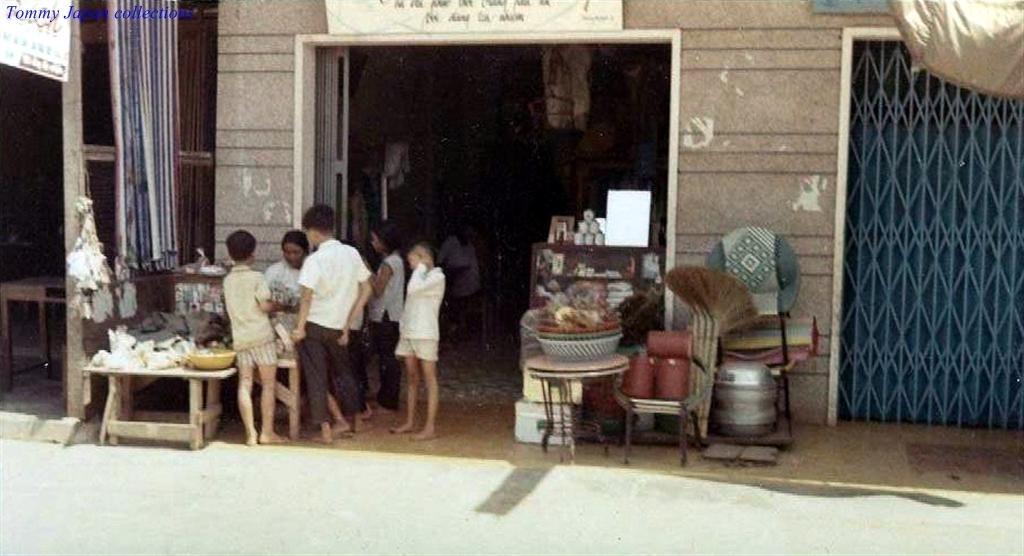In one or two sentences, can you explain what this image depicts? In this picture there are few children standing. It seems to be an entrance. To the left of the door there is a table and on it there are packets and a basket. To the right of the door there are baskets, broomsticks, mats and cans. To the right corner of the image there is grill. To the left corner there is curtain. To the top left corner there is text on the image.  